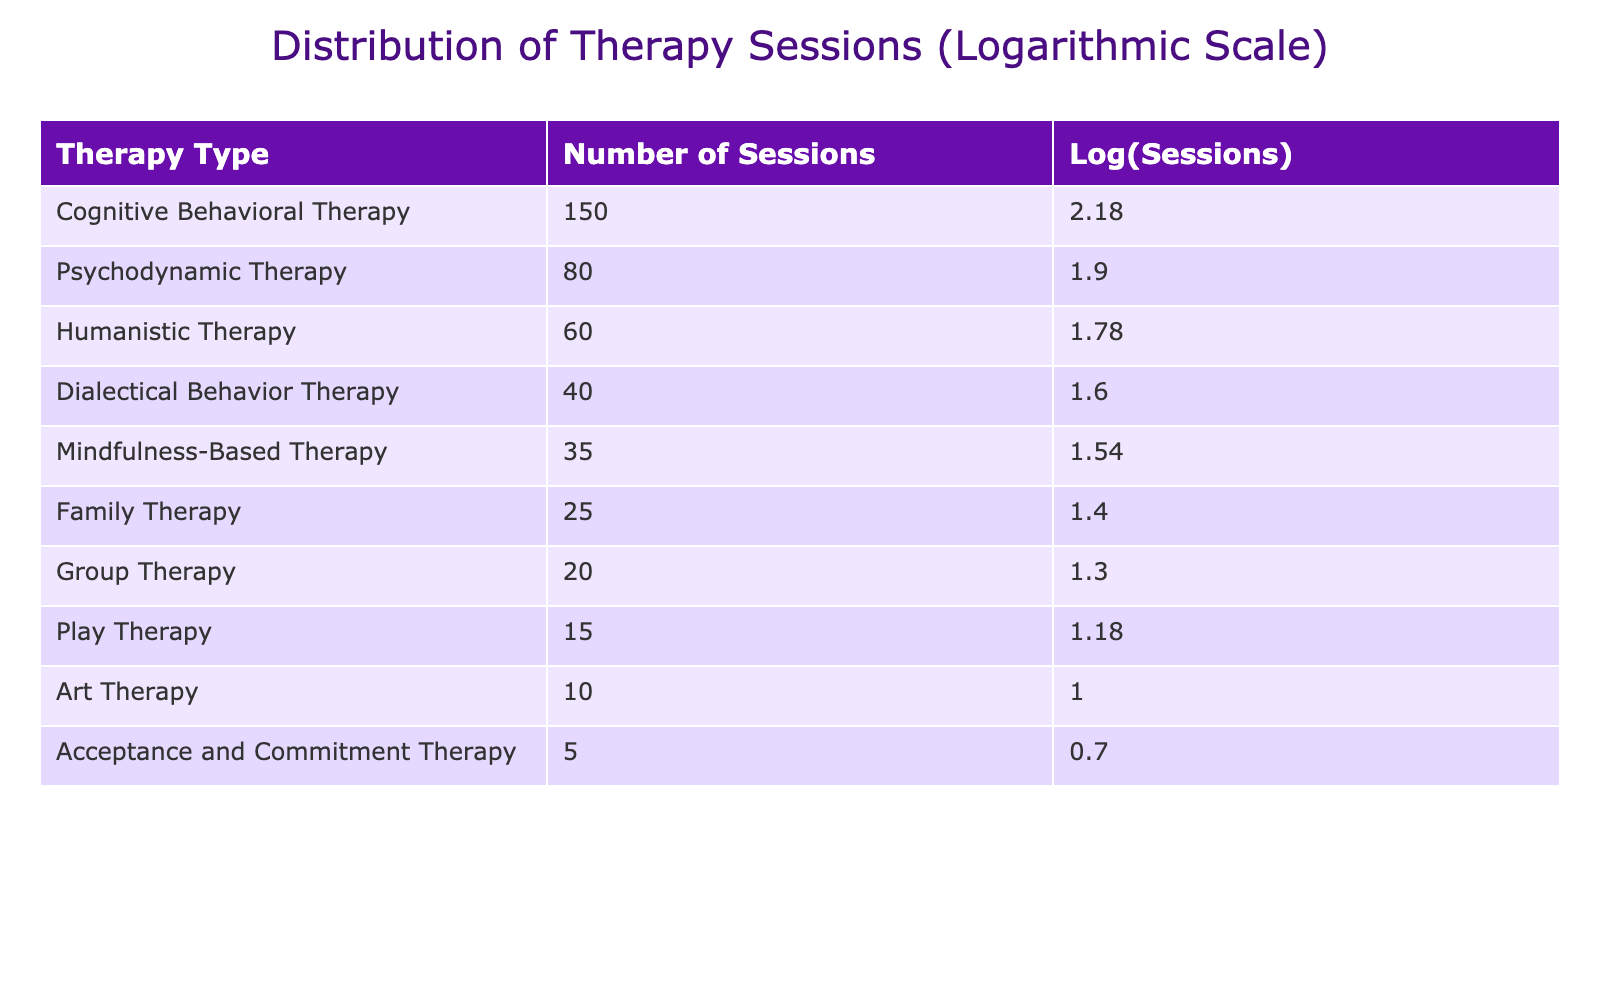What is the total number of sessions across all therapy types? To find the total number of sessions, we add the entries in the "Number of Sessions" column. The values are 150 + 80 + 60 + 40 + 35 + 25 + 20 + 15 + 10 + 5 = 420.
Answer: 420 Which therapy type has the highest number of sessions? Looking at the "Number of Sessions" column, Cognitive Behavioral Therapy has the highest value at 150.
Answer: Cognitive Behavioral Therapy Is the number of sessions for Mindfulness-Based Therapy greater than the combined sessions of Family Therapy and Group Therapy? Mindfulness-Based Therapy has 35 sessions, Family Therapy has 25 sessions, and Group Therapy has 20 sessions. Adding the sessions for Family and Group therapies gives us 25 + 20 = 45, which is greater than 35. Thus, the statement is false.
Answer: No What is the average number of sessions for all therapy types? To calculate the average, we divide the total number of sessions (420) by the number of therapy types (10). Thus, 420 / 10 = 42.
Answer: 42 Is the logarithmic value of sessions for Play Therapy greater than the logarithmic value for Acceptance and Commitment Therapy? For Play Therapy, the number of sessions is 15, and for Acceptance and Commitment Therapy, it is 5. The logarithmic values are log10(15) ≈ 1.18 and log10(5) ≈ 0.70. Since 1.18 is greater than 0.70, the statement is true.
Answer: Yes What is the difference in the number of sessions between the therapy type with the most sessions and the therapy type with the least sessions? The most sessions are from Cognitive Behavioral Therapy with 150, and the least sessions are from Acceptance and Commitment Therapy with 5. The difference is 150 - 5 = 145.
Answer: 145 Which therapy type, besides Cognitive Behavioral Therapy, has a number of sessions greater than 70? We check each therapy type: Psychodynamic Therapy (80) is the only one greater than 70.
Answer: Psychodynamic Therapy How many therapy types have fewer than 30 sessions? Looking through the "Number of Sessions" values, Family Therapy (25), Group Therapy (20), Play Therapy (15), Art Therapy (10), and Acceptance and Commitment Therapy (5) are all fewer than 30, making a total of 5 therapy types.
Answer: 5 If you combine the number of sessions for Mindfulness-Based Therapy, Family Therapy, and Group Therapy, is the total greater than Cognitive Behavioral Therapy's sessions? Adding Mindfulness-Based Therapy (35), Family Therapy (25), and Group Therapy (20) gives us 35 + 25 + 20 = 80. Since Cognitive Behavioral Therapy has 150 sessions, 80 is less than 150, so the statement is false.
Answer: No 